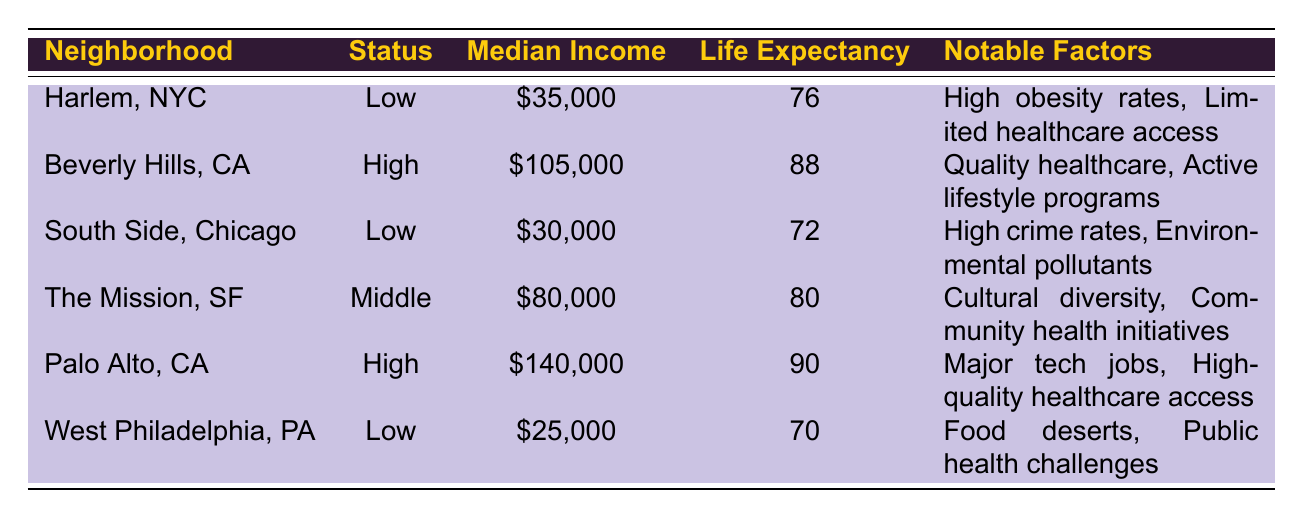What is the life expectancy in Harlem, NYC? The table lists the life expectancy in Harlem, NYC as 76. This information can be found in the “Life Expectancy” column corresponding to the “Harlem, NYC” row.
Answer: 76 What notable factors are listed for Beverly Hills, CA? According to the table, the notable factors for Beverly Hills, CA are "Access to quality healthcare" and "Active lifestyle programs." These factors are specified in the row dedicated to Beverly Hills.
Answer: Access to quality healthcare, Active lifestyle programs Which neighborhood has the lowest median income? The table shows that West Philadelphia, PA has the lowest median income at $25,000. This can be determined by comparing the median income values in the respective rows.
Answer: West Philadelphia, PA What is the average life expectancy of the low-income neighborhoods? The low-income neighborhoods listed are Harlem, South Side, and West Philadelphia with life expectancies of 76, 72, and 70 respectively. The average is calculated as (76 + 72 + 70) / 3 = 72.67, which rounds to 73.
Answer: 73 Does the table indicate that cities with high income generally have a higher life expectancy? Yes, based on the data in the table, Beverly Hills and Palo Alto, both classified as high-income neighborhoods, have life expectancies of 88 and 90, whereas low-income neighborhoods have lower life expectancies. This trend suggests a correlation between income and life expectancy.
Answer: Yes What is the difference in life expectancy between the highest and lowest income neighborhoods? Palo Alto (high-income) has a life expectancy of 90, while West Philadelphia (low-income) has a life expectancy of 70. The difference is 90 - 70 = 20 years. Thus, the difference in life expectancy between these neighborhoods is 20 years.
Answer: 20 years How many neighborhoods have a life expectancy above 80? The neighborhoods with a life expectancy above 80 are Beverly Hills (88) and Palo Alto (90). Counting these, there are 2 neighborhoods that meet the criteria.
Answer: 2 What are the notable factors for South Side, Chicago? In the table, the notable factors for South Side, Chicago are "High crime rates" and "Environmental pollutants." This information is found in the corresponding row related to the South Side.
Answer: High crime rates, Environmental pollutants What is the median income of The Mission in San Francisco? The table indicates that the median income for The Mission, San Francisco is $80,000. This detail is present in the row for The Mission.
Answer: $80,000 